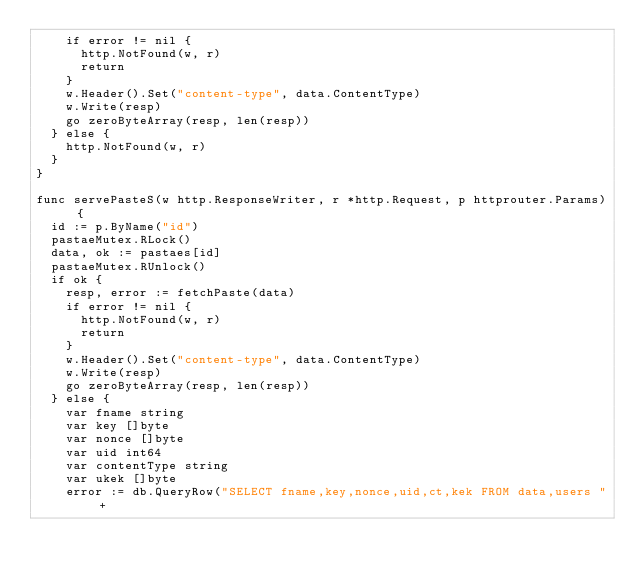Convert code to text. <code><loc_0><loc_0><loc_500><loc_500><_Go_>		if error != nil {
			http.NotFound(w, r)
			return
		}
		w.Header().Set("content-type", data.ContentType)
		w.Write(resp)
		go zeroByteArray(resp, len(resp))
	} else {
		http.NotFound(w, r)
	}
}

func servePasteS(w http.ResponseWriter, r *http.Request, p httprouter.Params) {
	id := p.ByName("id")
	pastaeMutex.RLock()
	data, ok := pastaes[id]
	pastaeMutex.RUnlock()
	if ok {
		resp, error := fetchPaste(data)
		if error != nil {
			http.NotFound(w, r)
			return
		}
		w.Header().Set("content-type", data.ContentType)
		w.Write(resp)
		go zeroByteArray(resp, len(resp))
	} else {
		var fname string
		var key []byte
		var nonce []byte
		var uid int64
		var contentType string
		var ukek []byte
		error := db.QueryRow("SELECT fname,key,nonce,uid,ct,kek FROM data,users "+</code> 